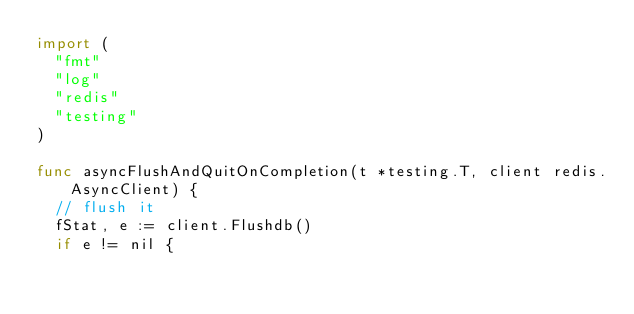Convert code to text. <code><loc_0><loc_0><loc_500><loc_500><_Go_>import (
	"fmt"
	"log"
	"redis"
	"testing"
)

func asyncFlushAndQuitOnCompletion(t *testing.T, client redis.AsyncClient) {
	// flush it
	fStat, e := client.Flushdb()
	if e != nil {</code> 